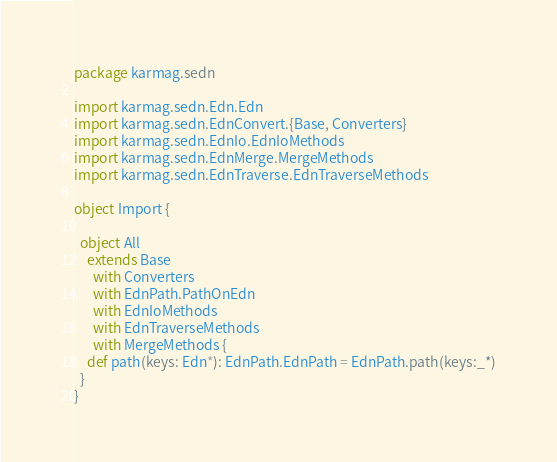Convert code to text. <code><loc_0><loc_0><loc_500><loc_500><_Scala_>package karmag.sedn

import karmag.sedn.Edn.Edn
import karmag.sedn.EdnConvert.{Base, Converters}
import karmag.sedn.EdnIo.EdnIoMethods
import karmag.sedn.EdnMerge.MergeMethods
import karmag.sedn.EdnTraverse.EdnTraverseMethods

object Import {

  object All
    extends Base
      with Converters
      with EdnPath.PathOnEdn
      with EdnIoMethods
      with EdnTraverseMethods
      with MergeMethods {
    def path(keys: Edn*): EdnPath.EdnPath = EdnPath.path(keys:_*)
  }
}
</code> 